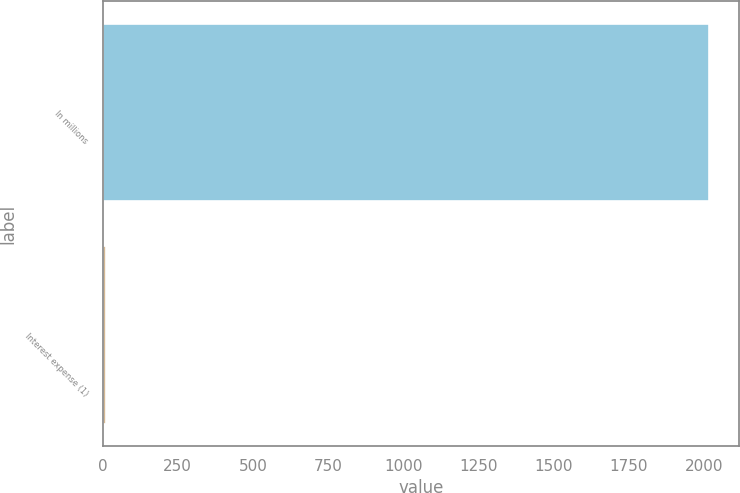<chart> <loc_0><loc_0><loc_500><loc_500><bar_chart><fcel>In millions<fcel>Interest expense (1)<nl><fcel>2016<fcel>12<nl></chart> 